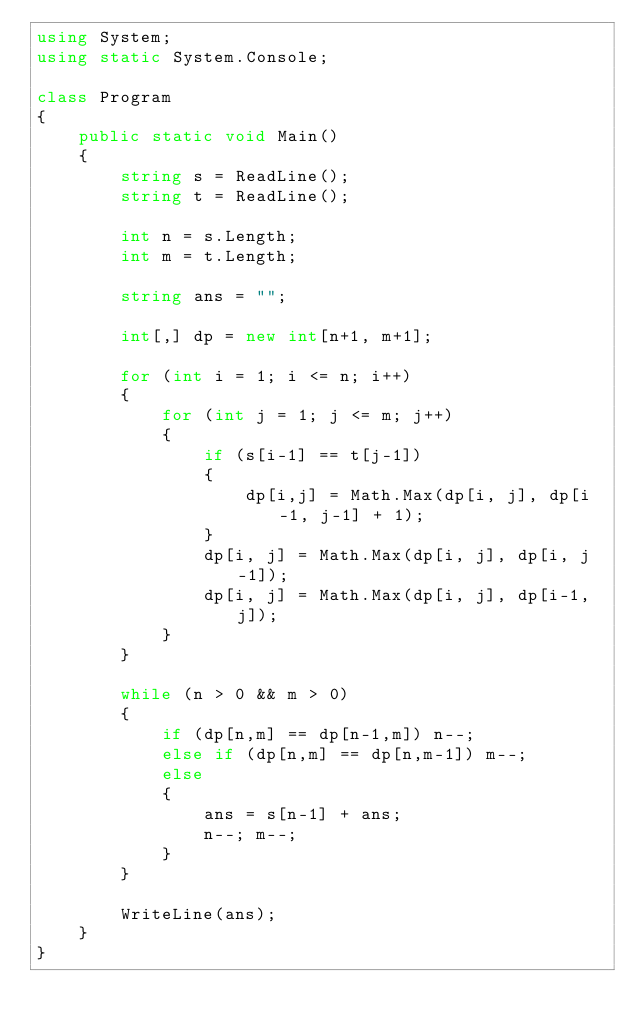<code> <loc_0><loc_0><loc_500><loc_500><_C#_>using System;
using static System.Console;

class Program
{
    public static void Main()
    {
        string s = ReadLine();
        string t = ReadLine();

        int n = s.Length;
        int m = t.Length;

        string ans = "";

        int[,] dp = new int[n+1, m+1];

        for (int i = 1; i <= n; i++)
        {
            for (int j = 1; j <= m; j++)
            {
                if (s[i-1] == t[j-1])
                {
                    dp[i,j] = Math.Max(dp[i, j], dp[i-1, j-1] + 1);
                }
                dp[i, j] = Math.Max(dp[i, j], dp[i, j-1]);
                dp[i, j] = Math.Max(dp[i, j], dp[i-1, j]);
            }
        }

        while (n > 0 && m > 0)
        {
            if (dp[n,m] == dp[n-1,m]) n--;
            else if (dp[n,m] == dp[n,m-1]) m--;
            else
            {
                ans = s[n-1] + ans;
                n--; m--;
            }
        }

        WriteLine(ans);
    }
}</code> 